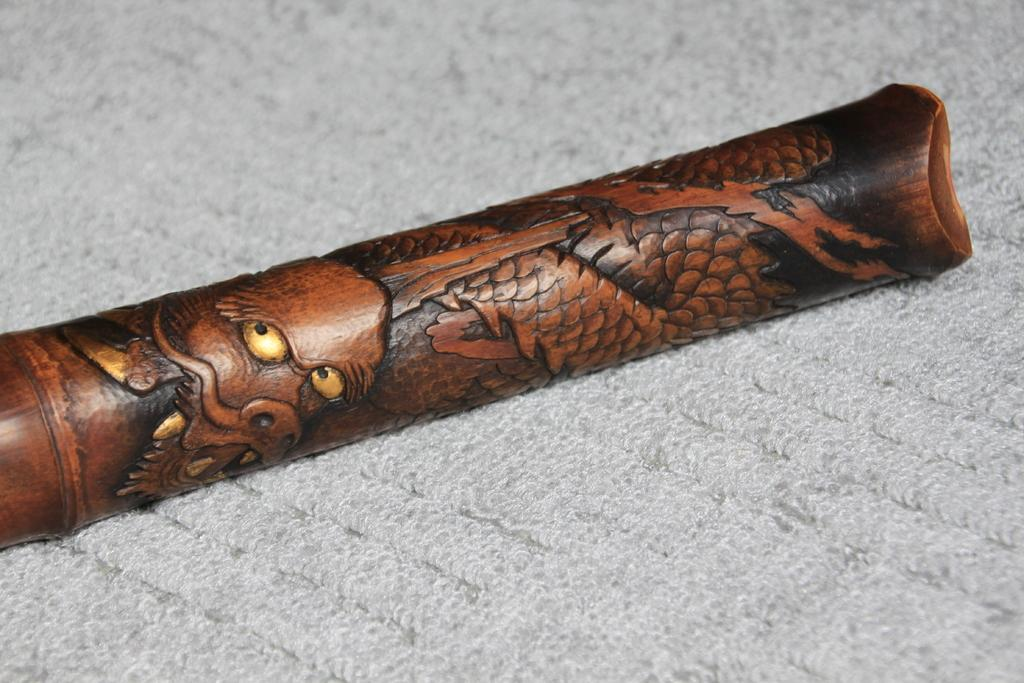What is the main object in the image? There is a rifle in the image. How is the rifle positioned in the image? The rifle is placed on a cloth. What type of engine can be seen powering the ice in the image? There is no ice or engine present in the image; it features a rifle placed on a cloth. 